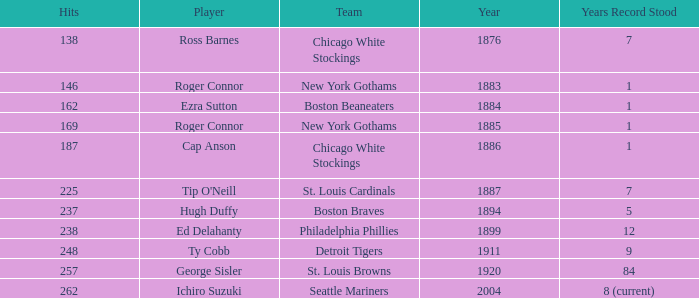Identify the hit tracks from years preceding 188 138.0. 